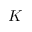<formula> <loc_0><loc_0><loc_500><loc_500>K</formula> 